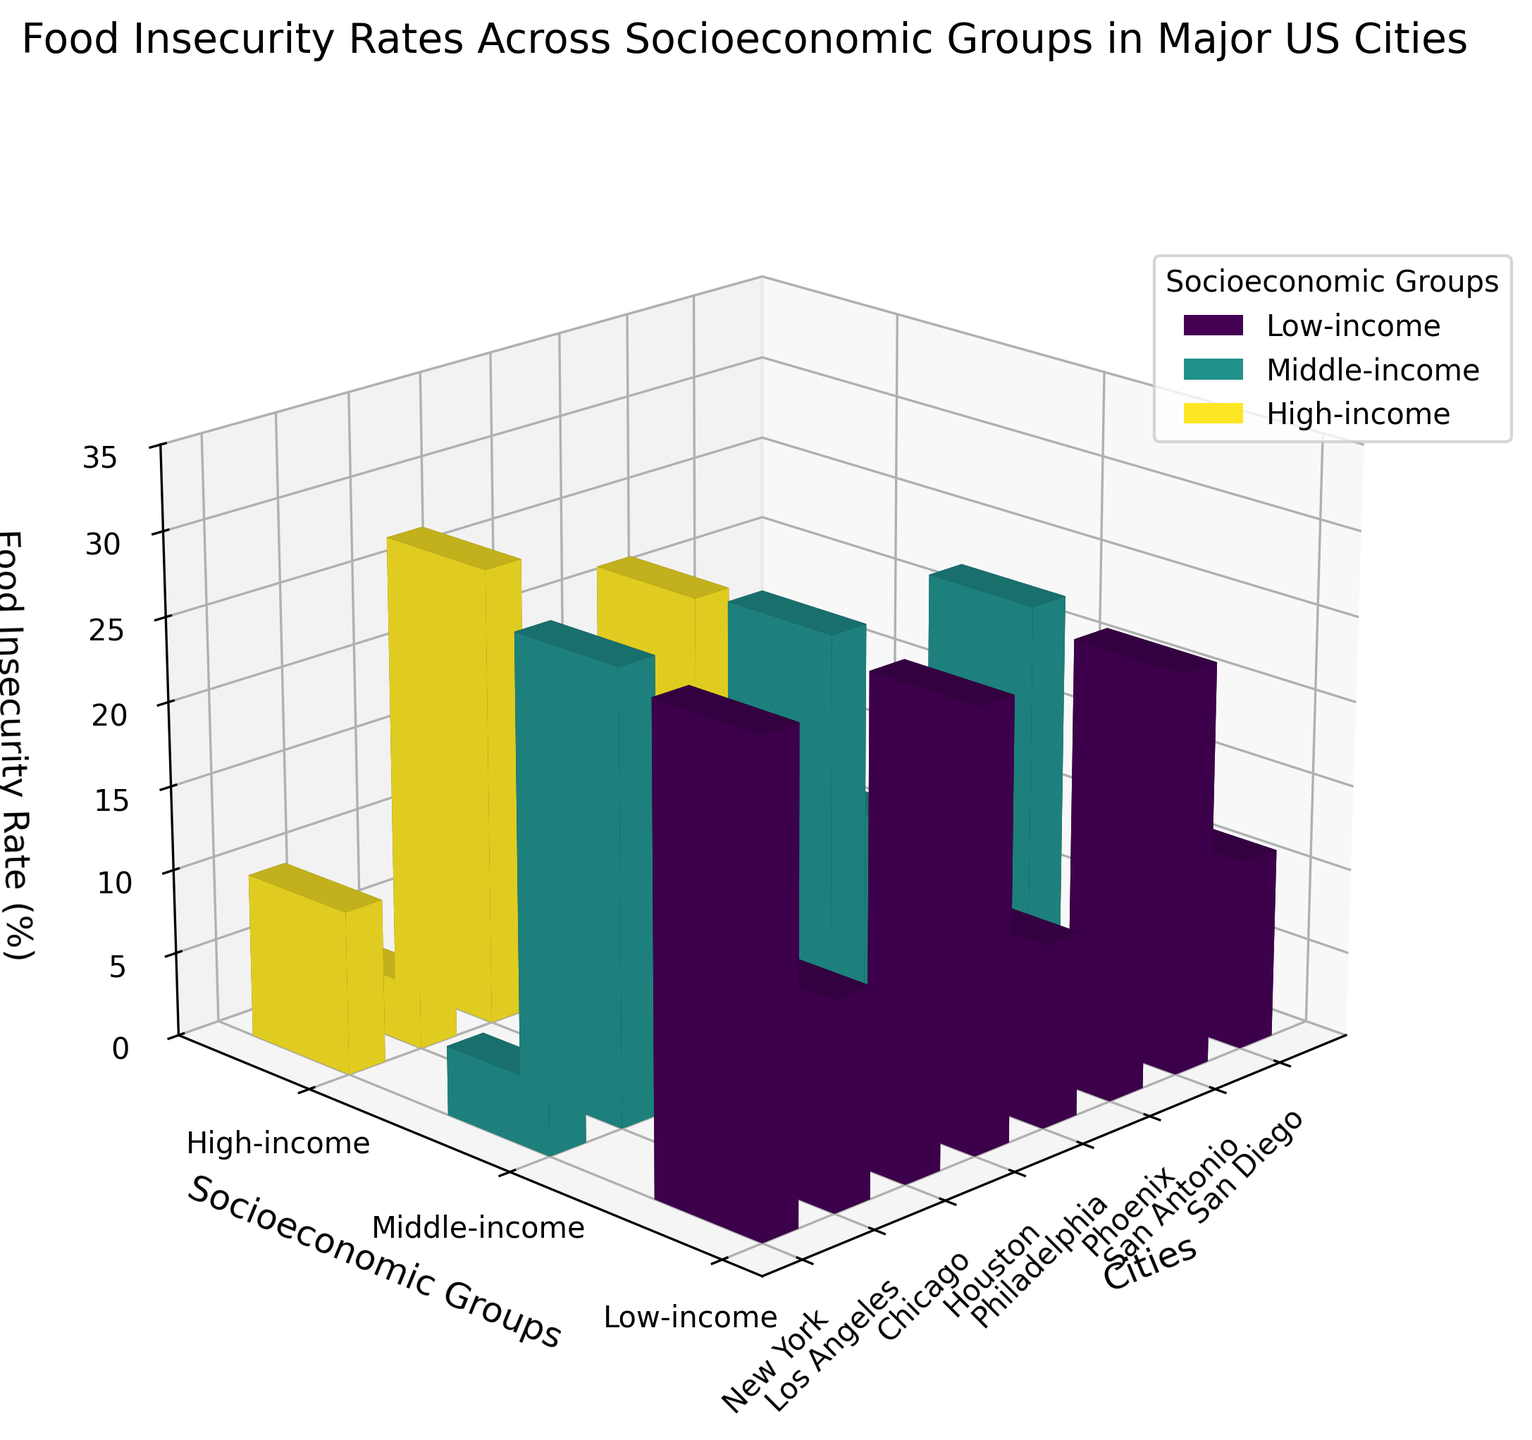What is the title of the figure? The title of a figure is typically found at the top and provides a summary of what the figure represents. In this case, it reads "Food Insecurity Rates Across Socioeconomic Groups in Major US Cities."
Answer: Food Insecurity Rates Across Socioeconomic Groups in Major US Cities Which cities are displayed on the x-axis? The x-axis in the figure is labeled 'Cities', and it contains the names of the cities. By looking at the x-axis ticks, we can identify the cities included.
Answer: New York, Los Angeles, Chicago, Houston, Philadelphia, Phoenix, San Antonio, San Diego What color is used to represent the low-income group in the figure? The figure uses a color gradient to represent different socioeconomic groups, and the low-income group is represented by one of these colors. The legend indicates the colors used for each group.
Answer: It's the darkest color in the gradient, often a shade of blue or purple Which city has the highest food insecurity rate among high-income groups? To determine this, we refer to the bars in the high-income group category and find the tallest bar. According to the z-axis, this value is highest for Houston.
Answer: Houston What is the difference in food insecurity rates between the low-income group and the high-income group in New York? First, we find the food insecurity rates for each group in New York from the z-axis, which are 28.5% for low-income and 4.7% for high-income. Then, we subtract the high-income rate from the low-income rate.
Answer: 28.5 - 4.7 = 23.8 Which socioeconomic group shows the least variability in food insecurity rates across the cities? This requires examining the height of bars for each group across all cities and determining the group with the least variation in bar heights. The high-income group bars, which are consistently low across all cities, show the least variability.
Answer: High-income Arrange the cities in descending order of food insecurity rates for the middle-income group. We need to look at the height of the bars denoting the middle-income groups across all cities and arrange them from highest to lowest.
Answer: San Antonio, Houston, New York, Philadelphia, Chicago, Los Angeles, Phoenix, San Diego Between Philadelphia and Phoenix, which city has a greater difference in food insecurity rates between low-income and middle-income groups? For Philadelphia: 24.6% (low-income) - 11.9% (middle-income) = 12.7%. For Phoenix: 22.3% (low-income) - 9.7% (middle-income) = 12.6%. We compare these differences to find the larger one.
Answer: Philadelphia (12.7% vs 12.6%) What is the average food insecurity rate for high-income groups across all cities? To find the average rate: (4.7 + 3.9 + 4.1 + 5.2 + 4.5 + 3.6 + 5.8 + 3.2) = 35. Average = 35 / 8.
Answer: 4.375 Which city has the lowest food insecurity rate among low-income groups? We compare the heights of bars representing the low-income group for each city using the z-axis. The city with the lowest bar height is San Diego, with a rate of 21.5%.
Answer: San Diego 